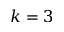<formula> <loc_0><loc_0><loc_500><loc_500>k = 3</formula> 